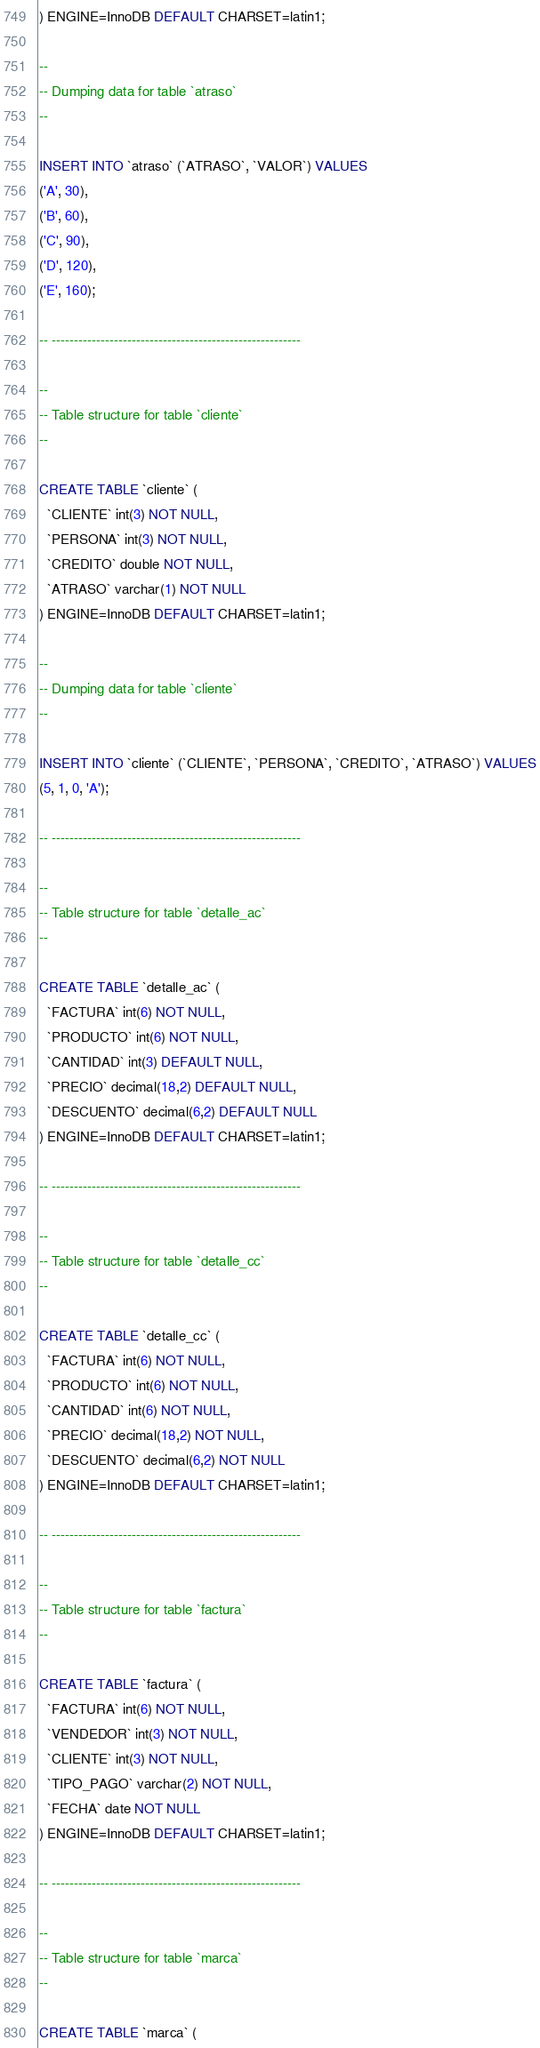Convert code to text. <code><loc_0><loc_0><loc_500><loc_500><_SQL_>) ENGINE=InnoDB DEFAULT CHARSET=latin1;

--
-- Dumping data for table `atraso`
--

INSERT INTO `atraso` (`ATRASO`, `VALOR`) VALUES
('A', 30),
('B', 60),
('C', 90),
('D', 120),
('E', 160);

-- --------------------------------------------------------

--
-- Table structure for table `cliente`
--

CREATE TABLE `cliente` (
  `CLIENTE` int(3) NOT NULL,
  `PERSONA` int(3) NOT NULL,
  `CREDITO` double NOT NULL,
  `ATRASO` varchar(1) NOT NULL
) ENGINE=InnoDB DEFAULT CHARSET=latin1;

--
-- Dumping data for table `cliente`
--

INSERT INTO `cliente` (`CLIENTE`, `PERSONA`, `CREDITO`, `ATRASO`) VALUES
(5, 1, 0, 'A');

-- --------------------------------------------------------

--
-- Table structure for table `detalle_ac`
--

CREATE TABLE `detalle_ac` (
  `FACTURA` int(6) NOT NULL,
  `PRODUCTO` int(6) NOT NULL,
  `CANTIDAD` int(3) DEFAULT NULL,
  `PRECIO` decimal(18,2) DEFAULT NULL,
  `DESCUENTO` decimal(6,2) DEFAULT NULL
) ENGINE=InnoDB DEFAULT CHARSET=latin1;

-- --------------------------------------------------------

--
-- Table structure for table `detalle_cc`
--

CREATE TABLE `detalle_cc` (
  `FACTURA` int(6) NOT NULL,
  `PRODUCTO` int(6) NOT NULL,
  `CANTIDAD` int(6) NOT NULL,
  `PRECIO` decimal(18,2) NOT NULL,
  `DESCUENTO` decimal(6,2) NOT NULL
) ENGINE=InnoDB DEFAULT CHARSET=latin1;

-- --------------------------------------------------------

--
-- Table structure for table `factura`
--

CREATE TABLE `factura` (
  `FACTURA` int(6) NOT NULL,
  `VENDEDOR` int(3) NOT NULL,
  `CLIENTE` int(3) NOT NULL,
  `TIPO_PAGO` varchar(2) NOT NULL,
  `FECHA` date NOT NULL
) ENGINE=InnoDB DEFAULT CHARSET=latin1;

-- --------------------------------------------------------

--
-- Table structure for table `marca`
--

CREATE TABLE `marca` (</code> 